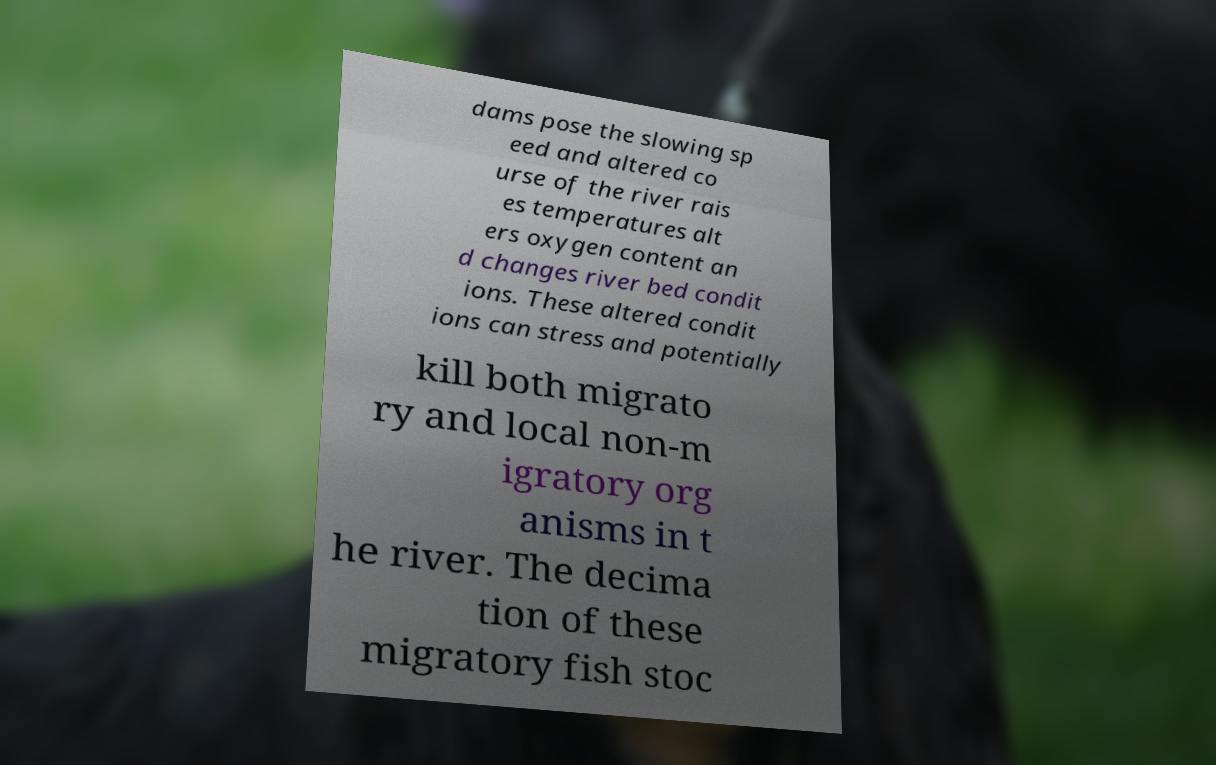Could you extract and type out the text from this image? dams pose the slowing sp eed and altered co urse of the river rais es temperatures alt ers oxygen content an d changes river bed condit ions. These altered condit ions can stress and potentially kill both migrato ry and local non-m igratory org anisms in t he river. The decima tion of these migratory fish stoc 